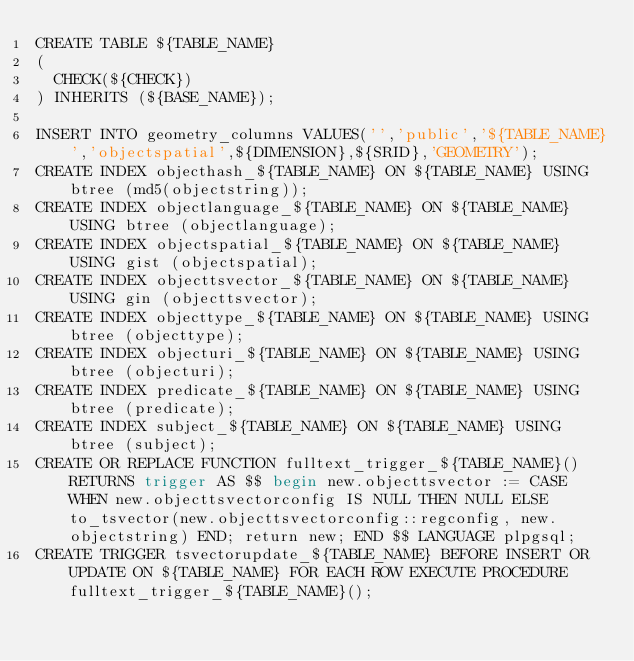<code> <loc_0><loc_0><loc_500><loc_500><_SQL_>CREATE TABLE ${TABLE_NAME}
(
  CHECK(${CHECK})
) INHERITS (${BASE_NAME});

INSERT INTO geometry_columns VALUES('','public','${TABLE_NAME}','objectspatial',${DIMENSION},${SRID},'GEOMETRY');
CREATE INDEX objecthash_${TABLE_NAME} ON ${TABLE_NAME} USING btree (md5(objectstring));
CREATE INDEX objectlanguage_${TABLE_NAME} ON ${TABLE_NAME} USING btree (objectlanguage);
CREATE INDEX objectspatial_${TABLE_NAME} ON ${TABLE_NAME} USING gist (objectspatial);
CREATE INDEX objecttsvector_${TABLE_NAME} ON ${TABLE_NAME} USING gin (objecttsvector);
CREATE INDEX objecttype_${TABLE_NAME} ON ${TABLE_NAME} USING btree (objecttype);
CREATE INDEX objecturi_${TABLE_NAME} ON ${TABLE_NAME} USING btree (objecturi);
CREATE INDEX predicate_${TABLE_NAME} ON ${TABLE_NAME} USING btree (predicate);
CREATE INDEX subject_${TABLE_NAME} ON ${TABLE_NAME} USING btree (subject);
CREATE OR REPLACE FUNCTION fulltext_trigger_${TABLE_NAME}() RETURNS trigger AS $$ begin new.objecttsvector := CASE WHEN new.objecttsvectorconfig IS NULL THEN NULL ELSE to_tsvector(new.objecttsvectorconfig::regconfig, new.objectstring) END; return new; END $$ LANGUAGE plpgsql;
CREATE TRIGGER tsvectorupdate_${TABLE_NAME} BEFORE INSERT OR UPDATE ON ${TABLE_NAME} FOR EACH ROW EXECUTE PROCEDURE fulltext_trigger_${TABLE_NAME}();</code> 